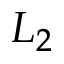Convert formula to latex. <formula><loc_0><loc_0><loc_500><loc_500>L _ { 2 }</formula> 